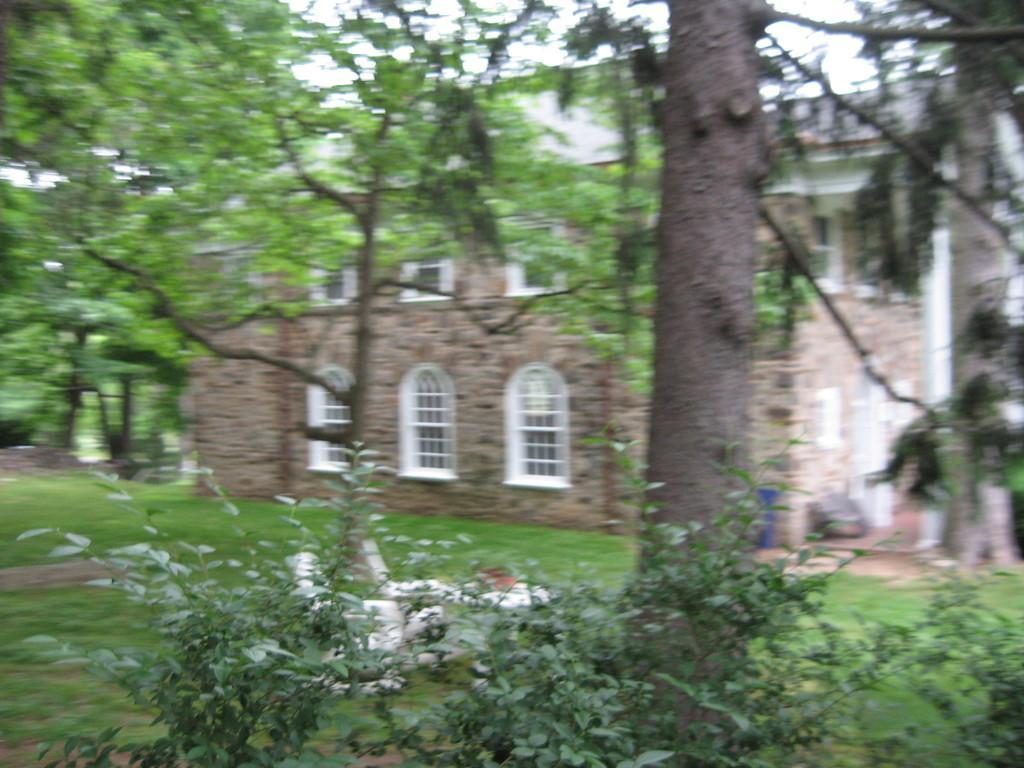Could you give a brief overview of what you see in this image? In this picture in the front there are plants in the center, there is grass on the ground and there is an object which is white in colour. In the background there is a building and there are trees. 